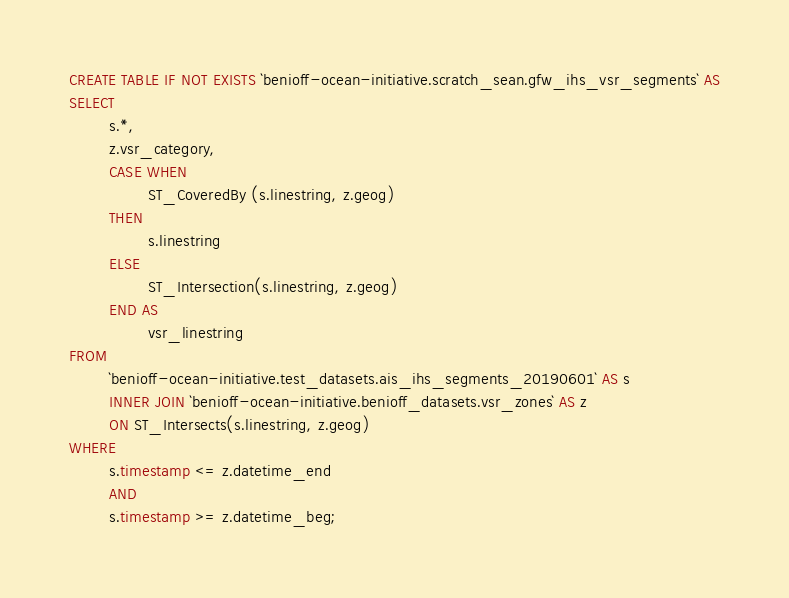Convert code to text. <code><loc_0><loc_0><loc_500><loc_500><_SQL_>CREATE TABLE IF NOT EXISTS `benioff-ocean-initiative.scratch_sean.gfw_ihs_vsr_segments` AS
SELECT
        s.*,
        z.vsr_category,
        CASE WHEN 
                ST_CoveredBy (s.linestring, z.geog) 
        THEN
                s.linestring
        ELSE
                ST_Intersection(s.linestring, z.geog)
        END AS 
                vsr_linestring
FROM
        `benioff-ocean-initiative.test_datasets.ais_ihs_segments_20190601` AS s
        INNER JOIN `benioff-ocean-initiative.benioff_datasets.vsr_zones` AS z 
        ON ST_Intersects(s.linestring, z.geog)
WHERE
        s.timestamp <= z.datetime_end
        AND 
        s.timestamp >= z.datetime_beg;</code> 